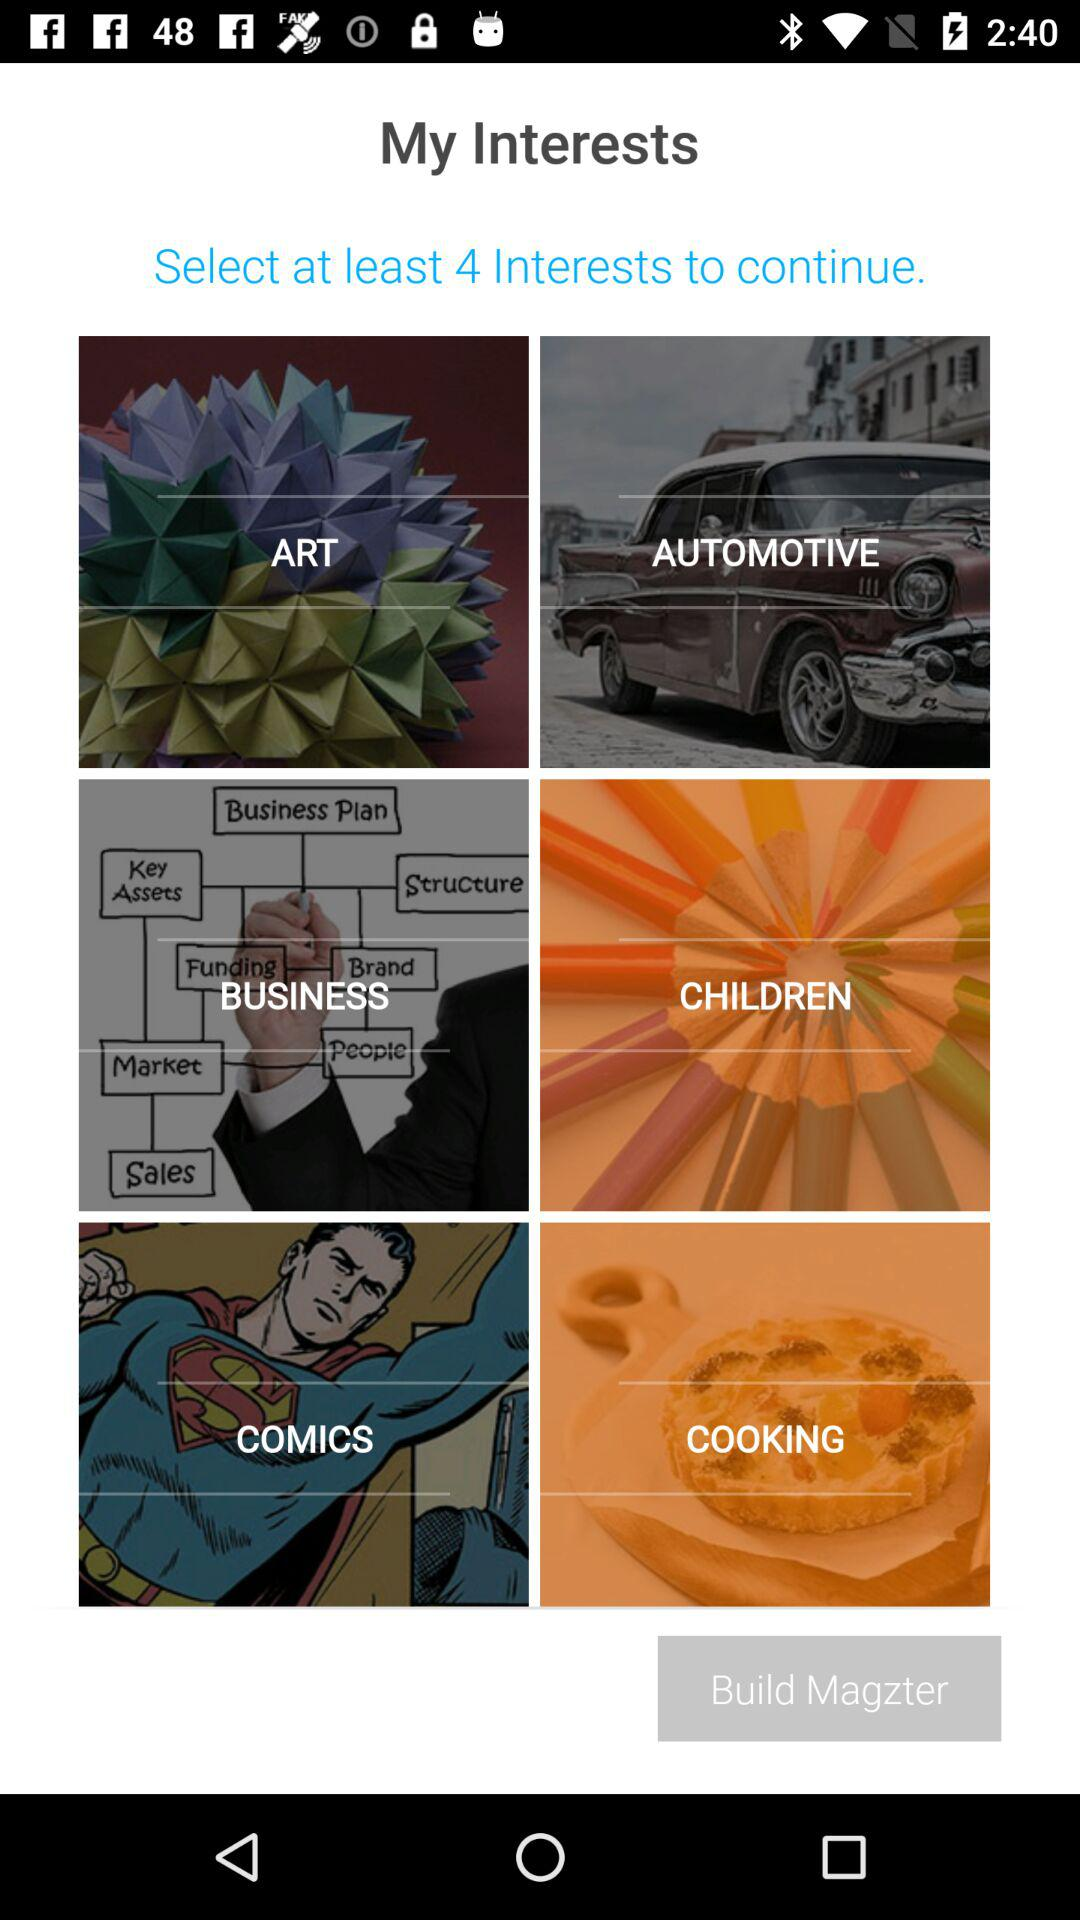How many interests are required to continue?
Answer the question using a single word or phrase. 4 